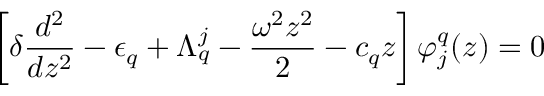<formula> <loc_0><loc_0><loc_500><loc_500>\left [ \delta \frac { d ^ { 2 } } { d z ^ { 2 } } - \epsilon _ { q } + \Lambda _ { q } ^ { j } - \frac { \omega ^ { 2 } z ^ { 2 } } { 2 } - c _ { q } z \right ] \varphi _ { j } ^ { q } ( z ) = 0</formula> 